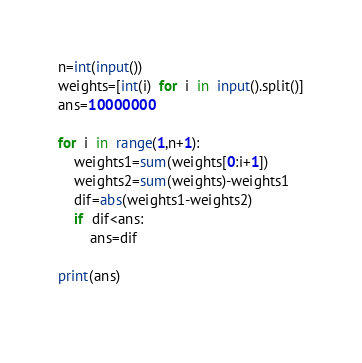Convert code to text. <code><loc_0><loc_0><loc_500><loc_500><_Python_>n=int(input())
weights=[int(i)  for  i  in  input().split()]
ans=10000000

for  i  in  range(1,n+1):
    weights1=sum(weights[0:i+1])
    weights2=sum(weights)-weights1
    dif=abs(weights1-weights2)
    if  dif<ans:
        ans=dif
    
print(ans)
        </code> 